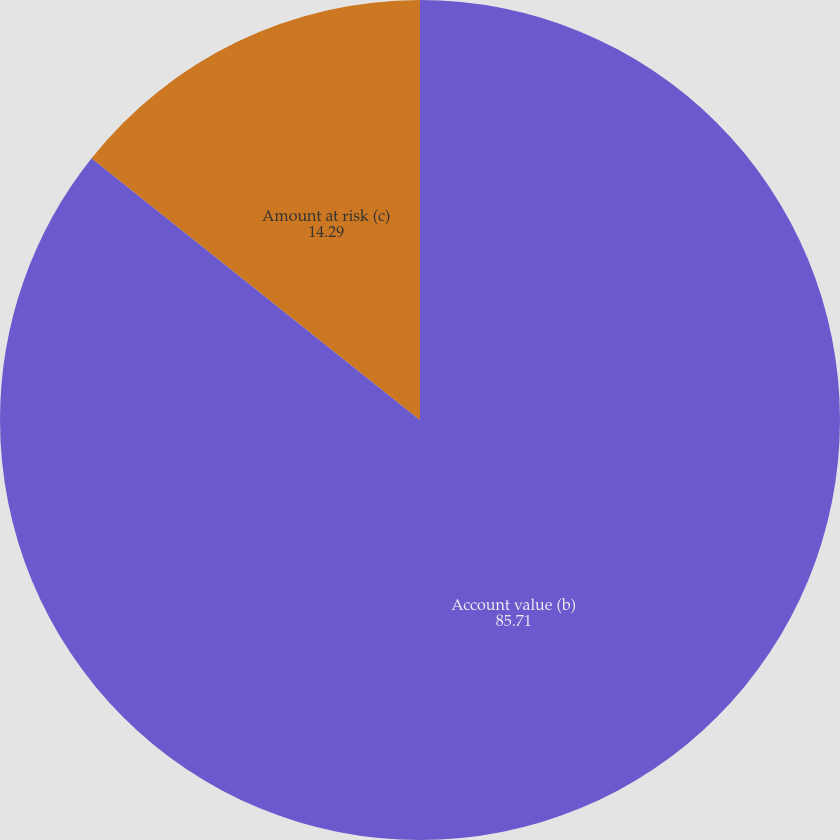Convert chart to OTSL. <chart><loc_0><loc_0><loc_500><loc_500><pie_chart><fcel>Account value (b)<fcel>Amount at risk (c)<nl><fcel>85.71%<fcel>14.29%<nl></chart> 